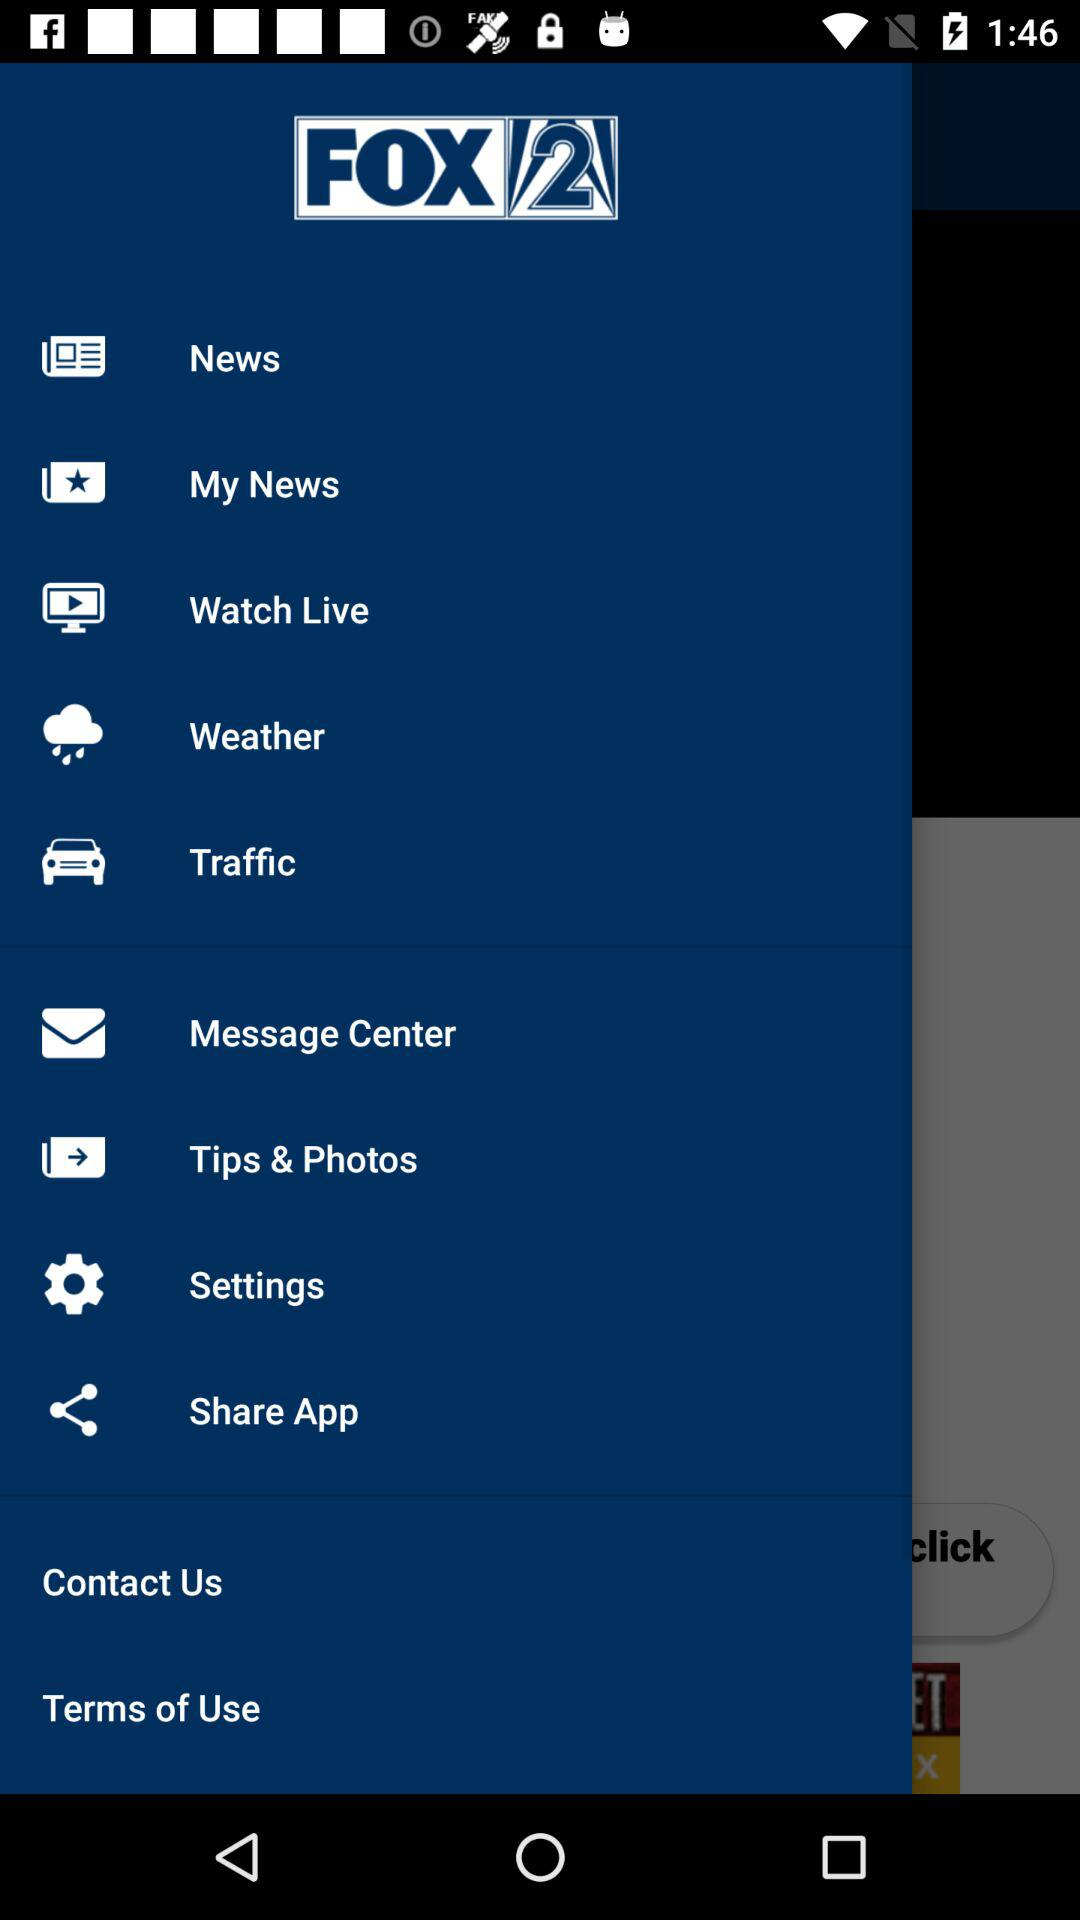What is the application name? The application name is "FOX 2". 